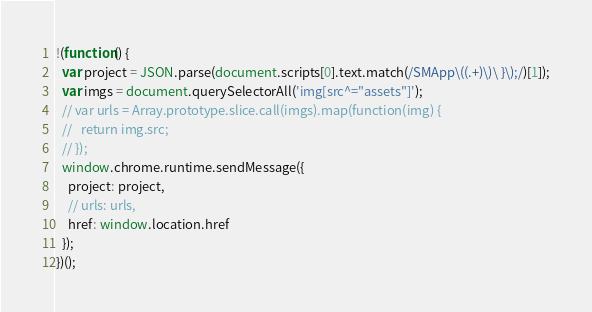Convert code to text. <code><loc_0><loc_0><loc_500><loc_500><_JavaScript_>!(function() {
  var project = JSON.parse(document.scripts[0].text.match(/SMApp\((.+)\)\ }\);/)[1]);
  var imgs = document.querySelectorAll('img[src^="assets"]');
  // var urls = Array.prototype.slice.call(imgs).map(function(img) {
  //   return img.src;
  // });
  window.chrome.runtime.sendMessage({
    project: project,
    // urls: urls, 
    href: window.location.href
  });
})();</code> 